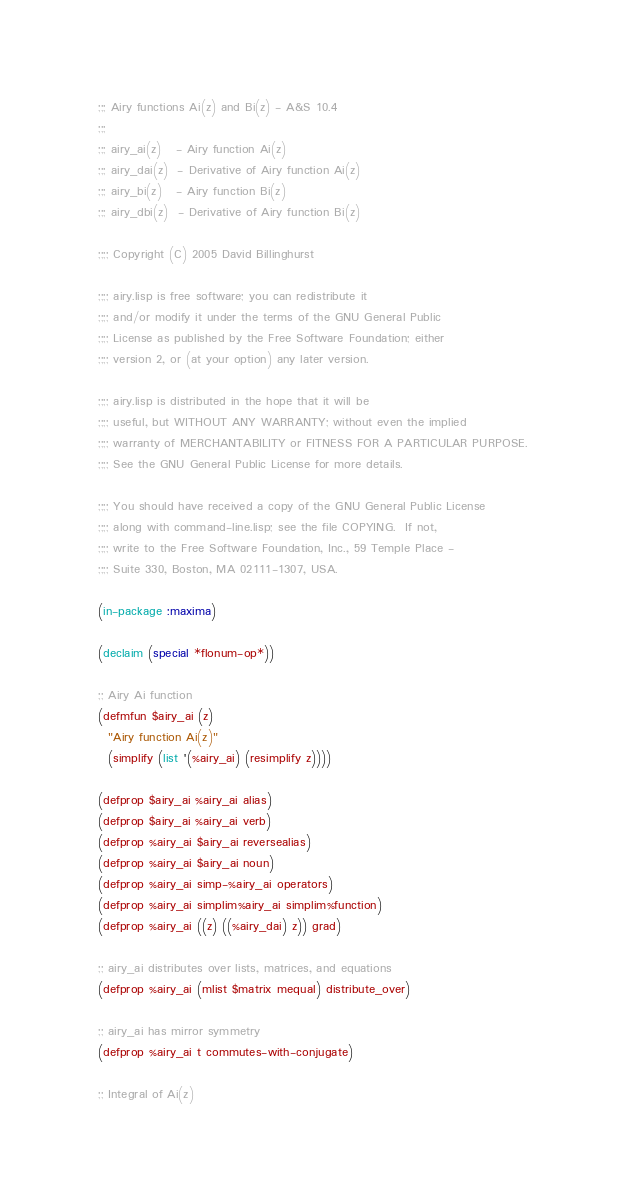Convert code to text. <code><loc_0><loc_0><loc_500><loc_500><_Lisp_>;;; Airy functions Ai(z) and Bi(z) - A&S 10.4
;;;
;;; airy_ai(z)   - Airy function Ai(z)
;;; airy_dai(z)  - Derivative of Airy function Ai(z)
;;; airy_bi(z)   - Airy function Bi(z)
;;; airy_dbi(z)  - Derivative of Airy function Bi(z)

;;;; Copyright (C) 2005 David Billinghurst

;;;; airy.lisp is free software; you can redistribute it
;;;; and/or modify it under the terms of the GNU General Public
;;;; License as published by the Free Software Foundation; either
;;;; version 2, or (at your option) any later version.

;;;; airy.lisp is distributed in the hope that it will be
;;;; useful, but WITHOUT ANY WARRANTY; without even the implied
;;;; warranty of MERCHANTABILITY or FITNESS FOR A PARTICULAR PURPOSE.
;;;; See the GNU General Public License for more details.

;;;; You should have received a copy of the GNU General Public License
;;;; along with command-line.lisp; see the file COPYING.  If not,
;;;; write to the Free Software Foundation, Inc., 59 Temple Place -
;;;; Suite 330, Boston, MA 02111-1307, USA.

(in-package :maxima)

(declaim (special *flonum-op*))

;; Airy Ai function 
(defmfun $airy_ai (z)
  "Airy function Ai(z)"
  (simplify (list '(%airy_ai) (resimplify z))))

(defprop $airy_ai %airy_ai alias)
(defprop $airy_ai %airy_ai verb)
(defprop %airy_ai $airy_ai reversealias)
(defprop %airy_ai $airy_ai noun)
(defprop %airy_ai simp-%airy_ai operators)
(defprop %airy_ai simplim%airy_ai simplim%function)
(defprop %airy_ai ((z) ((%airy_dai) z)) grad)

;; airy_ai distributes over lists, matrices, and equations
(defprop %airy_ai (mlist $matrix mequal) distribute_over)

;; airy_ai has mirror symmetry
(defprop %airy_ai t commutes-with-conjugate)

;; Integral of Ai(z)</code> 